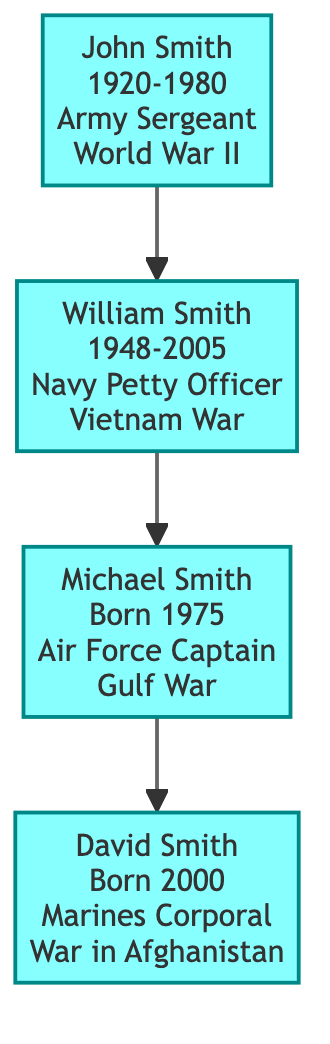What was the military branch of John Smith? The diagram indicates that John Smith served in the Army.
Answer: Army How many generations of military service are shown in the family tree? There are four generations represented in the family tree, starting with John Smith and ending with David Smith.
Answer: 4 What rank did William Smith achieve during his service? According to the diagram, William Smith held the rank of Petty Officer.
Answer: Petty Officer In which war did Michael Smith serve? The diagram specifies that Michael Smith served in the Gulf War.
Answer: Gulf War Who is the youngest person in the family tree? The diagram shows that David Smith, born in 2000, is the youngest individual in the family tree.
Answer: David Smith What was the year range of service for John Smith? The diagram states that John Smith served from 1941 to 1945.
Answer: 1941-1945 Which military branch did David Smith serve in? The diagram indicates that David Smith is serving in the Marines.
Answer: Marines What relationship does Michael Smith have with John Smith? The diagram shows a direct lineage from John Smith to his grandson Michael Smith, meaning they are grandfather and grandson.
Answer: Grandfather and Grandson What is the service status of David Smith? The diagram specifies that David Smith's service is current, noted as "2018-Present."
Answer: 2018-Present 